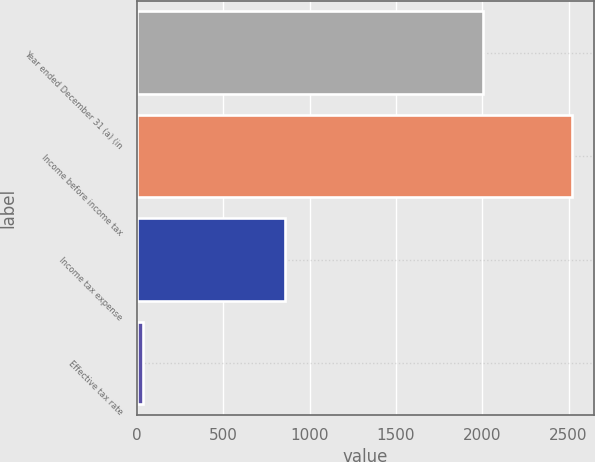<chart> <loc_0><loc_0><loc_500><loc_500><bar_chart><fcel>Year ended December 31 (a) (in<fcel>Income before income tax<fcel>Income tax expense<fcel>Effective tax rate<nl><fcel>2002<fcel>2519<fcel>856<fcel>34<nl></chart> 